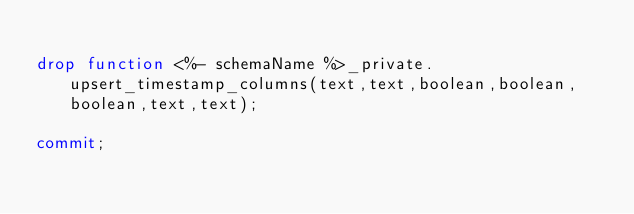<code> <loc_0><loc_0><loc_500><loc_500><_SQL_>
drop function <%- schemaName %>_private.upsert_timestamp_columns(text,text,boolean,boolean,boolean,text,text);

commit;
</code> 